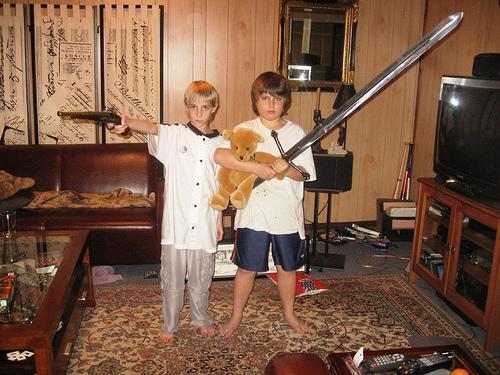What is the boy on the right holding?
Select the correct answer and articulate reasoning with the following format: 'Answer: answer
Rationale: rationale.'
Options: Sword, shield, pumpkin, mace. Answer: sword.
Rationale: The object looks metallic with a handle and symmetrical things under the blade. 